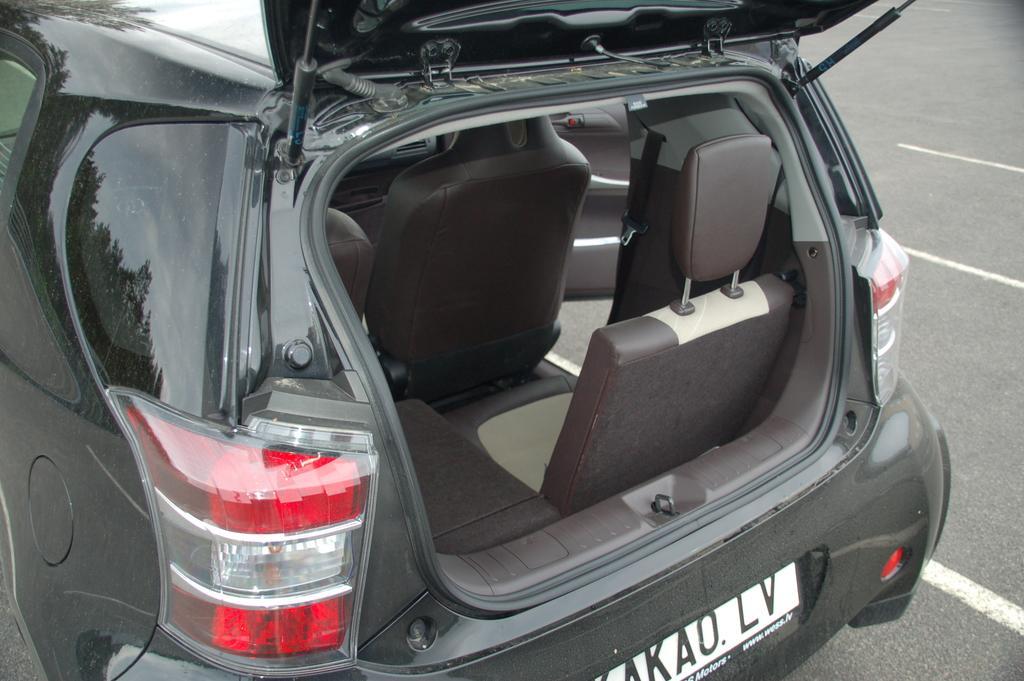How would you summarize this image in a sentence or two? This image is taken outdoors. On the right side of the image there is a road. On the left side of the image a car is parked on the road. The car black in color. 